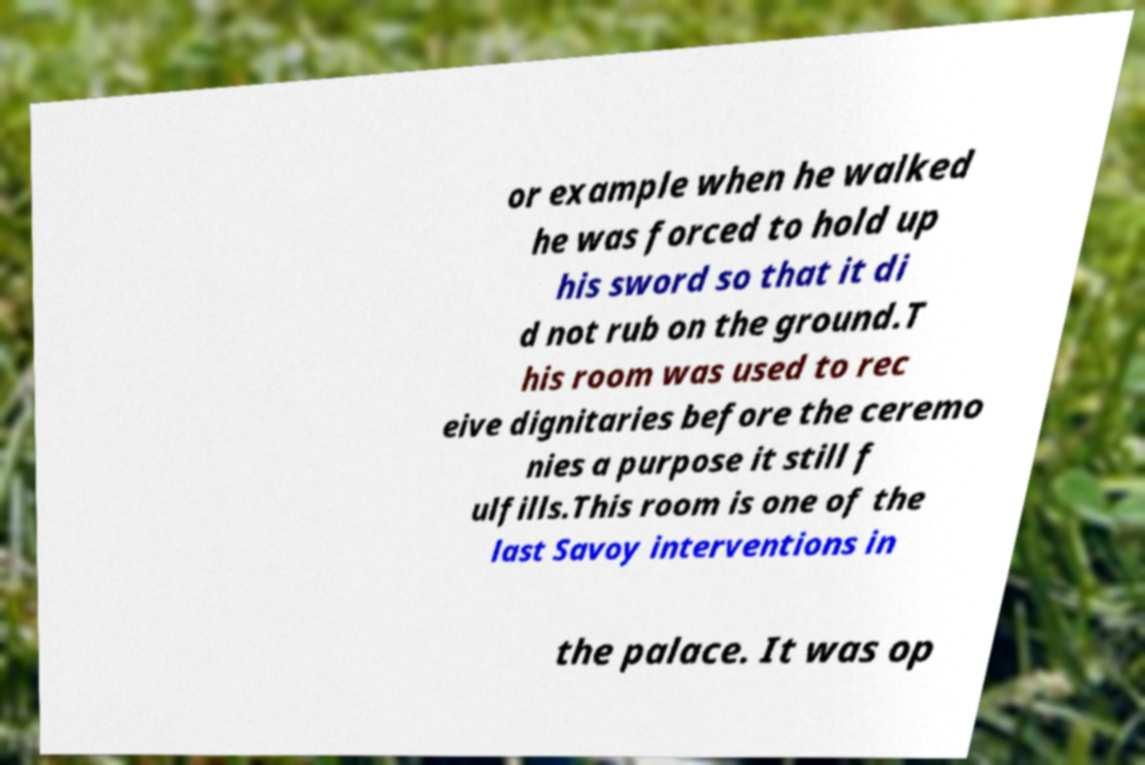Could you extract and type out the text from this image? or example when he walked he was forced to hold up his sword so that it di d not rub on the ground.T his room was used to rec eive dignitaries before the ceremo nies a purpose it still f ulfills.This room is one of the last Savoy interventions in the palace. It was op 